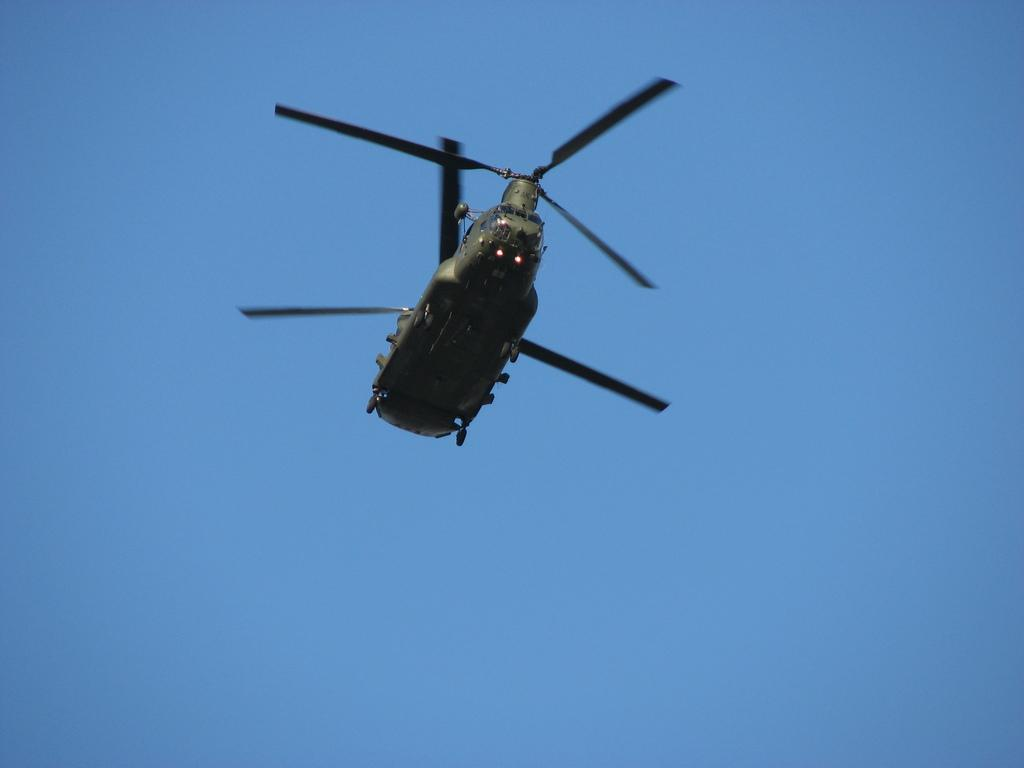What is the main subject of the image? The main subject of the image is a helicopter. Where is the helicopter located in the image? The helicopter is in the air. What color is the background of the image? The background of the image is blue. What type of knowledge can be seen being shared between the lettuce and the parent in the image? There is no lettuce or parent present in the image; it features a helicopter in the air with a blue background. 